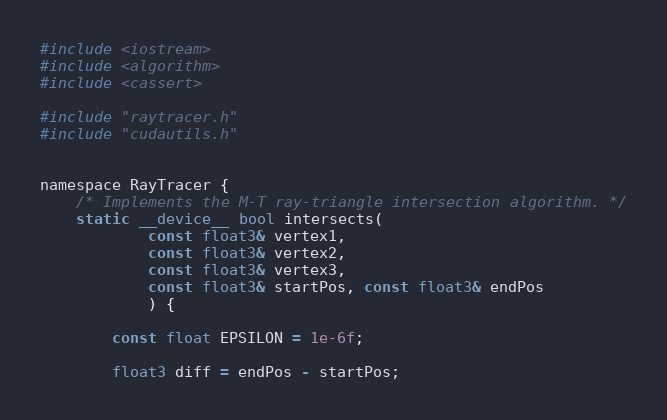Convert code to text. <code><loc_0><loc_0><loc_500><loc_500><_Cuda_>#include <iostream>
#include <algorithm>
#include <cassert>

#include "raytracer.h"
#include "cudautils.h"


namespace RayTracer {
    /* Implements the M-T ray-triangle intersection algorithm. */
    static __device__ bool intersects(
            const float3& vertex1,
            const float3& vertex2,
            const float3& vertex3,
            const float3& startPos, const float3& endPos
            ) {

        const float EPSILON = 1e-6f;

        float3 diff = endPos - startPos;</code> 